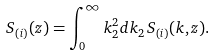<formula> <loc_0><loc_0><loc_500><loc_500>S _ { ( i ) } ( z ) = \int _ { 0 } ^ { \infty } k ^ { 2 } _ { 2 } d k _ { 2 } \, S _ { ( i ) } ( k , z ) .</formula> 